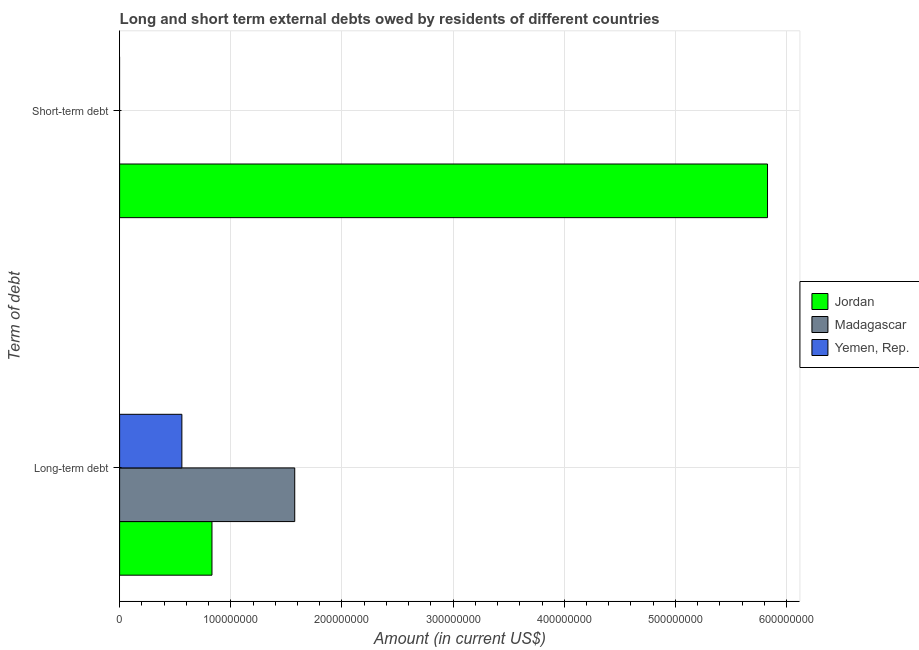Are the number of bars per tick equal to the number of legend labels?
Your answer should be compact. No. Are the number of bars on each tick of the Y-axis equal?
Provide a succinct answer. No. How many bars are there on the 2nd tick from the top?
Offer a terse response. 3. What is the label of the 1st group of bars from the top?
Make the answer very short. Short-term debt. Across all countries, what is the maximum short-term debts owed by residents?
Your response must be concise. 5.83e+08. Across all countries, what is the minimum short-term debts owed by residents?
Give a very brief answer. 0. In which country was the short-term debts owed by residents maximum?
Your answer should be very brief. Jordan. What is the total long-term debts owed by residents in the graph?
Offer a terse response. 2.97e+08. What is the difference between the long-term debts owed by residents in Madagascar and that in Yemen, Rep.?
Keep it short and to the point. 1.02e+08. What is the difference between the short-term debts owed by residents in Jordan and the long-term debts owed by residents in Yemen, Rep.?
Your response must be concise. 5.27e+08. What is the average long-term debts owed by residents per country?
Offer a terse response. 9.89e+07. What is the difference between the long-term debts owed by residents and short-term debts owed by residents in Jordan?
Your response must be concise. -5.00e+08. What is the ratio of the long-term debts owed by residents in Jordan to that in Madagascar?
Your answer should be very brief. 0.53. How many countries are there in the graph?
Your answer should be very brief. 3. What is the difference between two consecutive major ticks on the X-axis?
Offer a very short reply. 1.00e+08. Does the graph contain any zero values?
Offer a terse response. Yes. How many legend labels are there?
Offer a very short reply. 3. How are the legend labels stacked?
Your answer should be very brief. Vertical. What is the title of the graph?
Offer a terse response. Long and short term external debts owed by residents of different countries. What is the label or title of the Y-axis?
Your answer should be very brief. Term of debt. What is the Amount (in current US$) of Jordan in Long-term debt?
Give a very brief answer. 8.31e+07. What is the Amount (in current US$) in Madagascar in Long-term debt?
Offer a terse response. 1.58e+08. What is the Amount (in current US$) in Yemen, Rep. in Long-term debt?
Your answer should be compact. 5.60e+07. What is the Amount (in current US$) of Jordan in Short-term debt?
Your answer should be very brief. 5.83e+08. What is the Amount (in current US$) of Yemen, Rep. in Short-term debt?
Your answer should be very brief. 0. Across all Term of debt, what is the maximum Amount (in current US$) of Jordan?
Your response must be concise. 5.83e+08. Across all Term of debt, what is the maximum Amount (in current US$) in Madagascar?
Your response must be concise. 1.58e+08. Across all Term of debt, what is the maximum Amount (in current US$) in Yemen, Rep.?
Keep it short and to the point. 5.60e+07. Across all Term of debt, what is the minimum Amount (in current US$) in Jordan?
Provide a short and direct response. 8.31e+07. Across all Term of debt, what is the minimum Amount (in current US$) of Yemen, Rep.?
Provide a succinct answer. 0. What is the total Amount (in current US$) in Jordan in the graph?
Provide a short and direct response. 6.66e+08. What is the total Amount (in current US$) in Madagascar in the graph?
Make the answer very short. 1.58e+08. What is the total Amount (in current US$) in Yemen, Rep. in the graph?
Your answer should be very brief. 5.60e+07. What is the difference between the Amount (in current US$) of Jordan in Long-term debt and that in Short-term debt?
Your answer should be compact. -5.00e+08. What is the average Amount (in current US$) of Jordan per Term of debt?
Provide a succinct answer. 3.33e+08. What is the average Amount (in current US$) in Madagascar per Term of debt?
Your answer should be very brief. 7.88e+07. What is the average Amount (in current US$) in Yemen, Rep. per Term of debt?
Your response must be concise. 2.80e+07. What is the difference between the Amount (in current US$) in Jordan and Amount (in current US$) in Madagascar in Long-term debt?
Provide a short and direct response. -7.45e+07. What is the difference between the Amount (in current US$) in Jordan and Amount (in current US$) in Yemen, Rep. in Long-term debt?
Offer a very short reply. 2.71e+07. What is the difference between the Amount (in current US$) of Madagascar and Amount (in current US$) of Yemen, Rep. in Long-term debt?
Provide a succinct answer. 1.02e+08. What is the ratio of the Amount (in current US$) of Jordan in Long-term debt to that in Short-term debt?
Your answer should be compact. 0.14. What is the difference between the highest and the second highest Amount (in current US$) in Jordan?
Offer a terse response. 5.00e+08. What is the difference between the highest and the lowest Amount (in current US$) in Jordan?
Provide a short and direct response. 5.00e+08. What is the difference between the highest and the lowest Amount (in current US$) of Madagascar?
Provide a short and direct response. 1.58e+08. What is the difference between the highest and the lowest Amount (in current US$) in Yemen, Rep.?
Your answer should be very brief. 5.60e+07. 